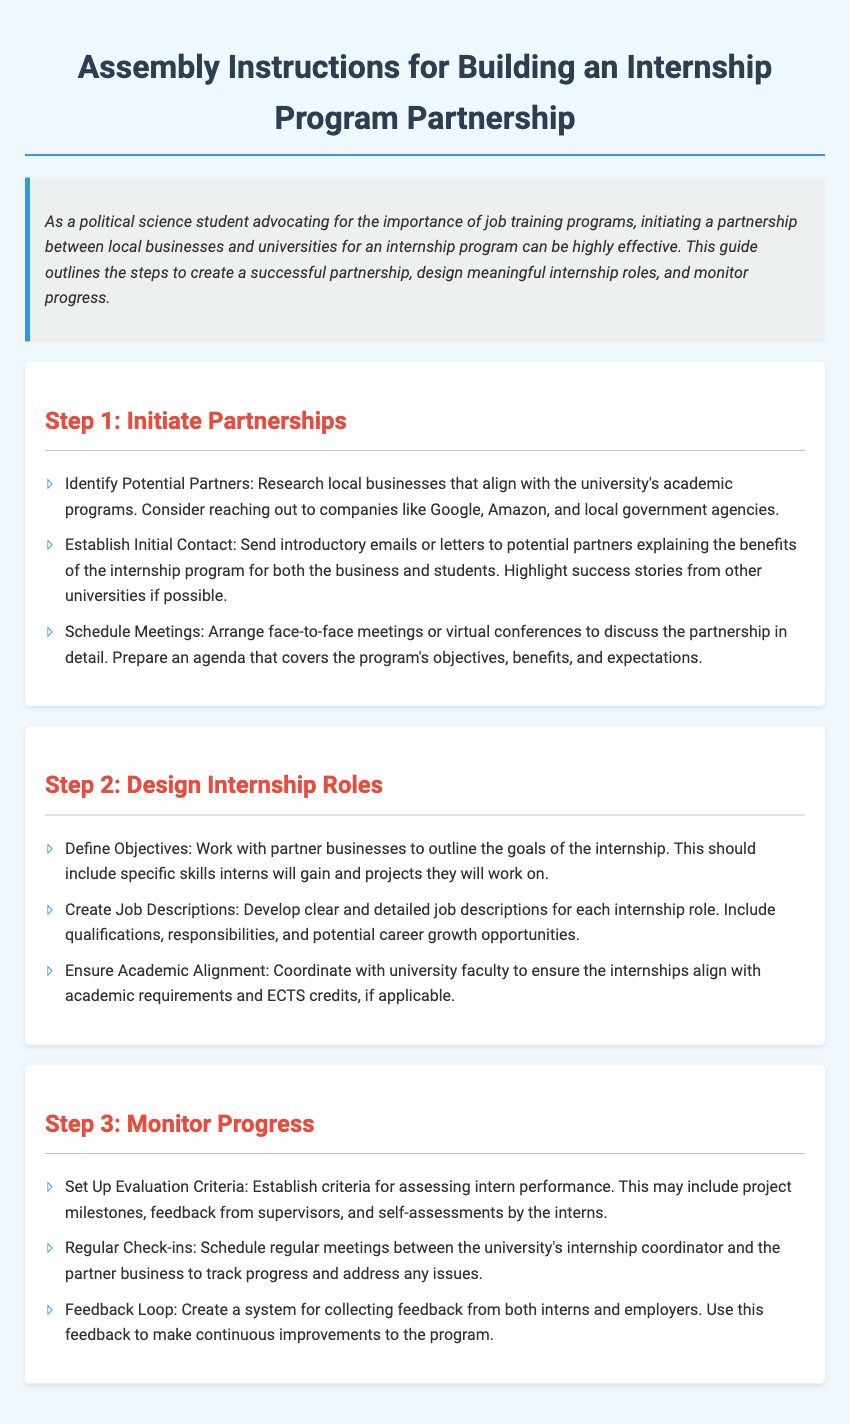what is the title of the document? The title is stated at the beginning of the document and sets the context for the contents.
Answer: Assembly Instructions for Building an Internship Program Partnership what is the first step in the partnership process? The document outlines the steps in a numbered format, beginning with Step 1: Initiate Partnerships.
Answer: Initiate Partnerships which businesses are suggested as potential partners? The document lists several potential partners that could align with academic programs in the partnership.
Answer: Google, Amazon, and local government agencies what is a key component of the internship role design? The document emphasizes working with partner businesses to outline specific skills and projects for interns.
Answer: Define Objectives how often should check-ins be scheduled? The document states the importance of scheduling regular meetings to track progress in the internship program.
Answer: Regularly what should be included in job descriptions? The document specifies information that job descriptions should contain for clarity and understanding.
Answer: Qualifications, responsibilities, and potential career growth opportunities what is the purpose of the feedback loop? The document highlights the role of feedback in improving the program based on insights from participants.
Answer: Continuous improvements how can progress be monitored according to the document? The document specifies methods for assessment and progress monitoring during the internship.
Answer: Evaluation criteria and regular check-ins 